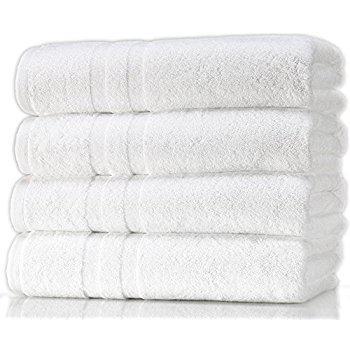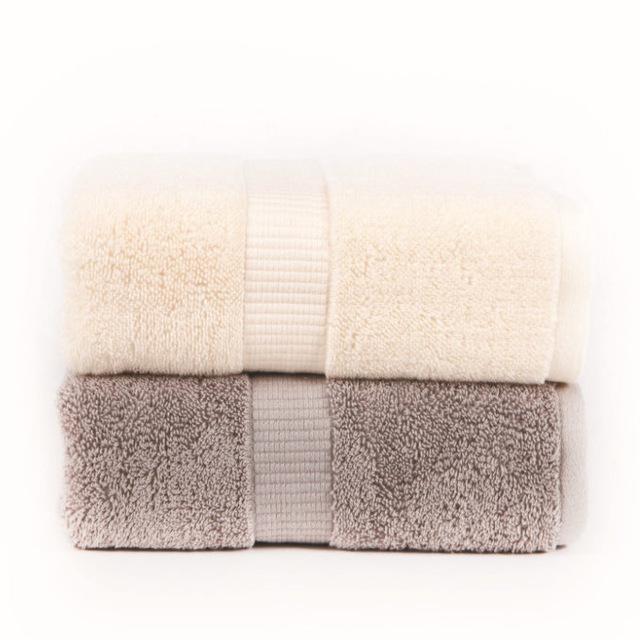The first image is the image on the left, the second image is the image on the right. Evaluate the accuracy of this statement regarding the images: "At least one of the towels is brown.". Is it true? Answer yes or no. Yes. The first image is the image on the left, the second image is the image on the right. For the images displayed, is the sentence "There are four towels in the right image." factually correct? Answer yes or no. No. 